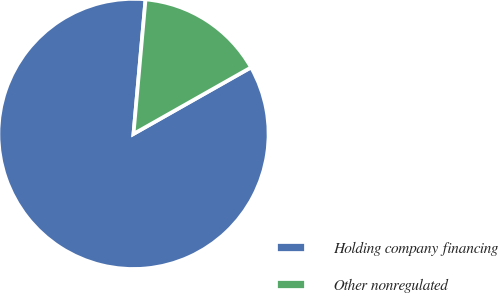<chart> <loc_0><loc_0><loc_500><loc_500><pie_chart><fcel>Holding company financing<fcel>Other nonregulated<nl><fcel>84.62%<fcel>15.38%<nl></chart> 